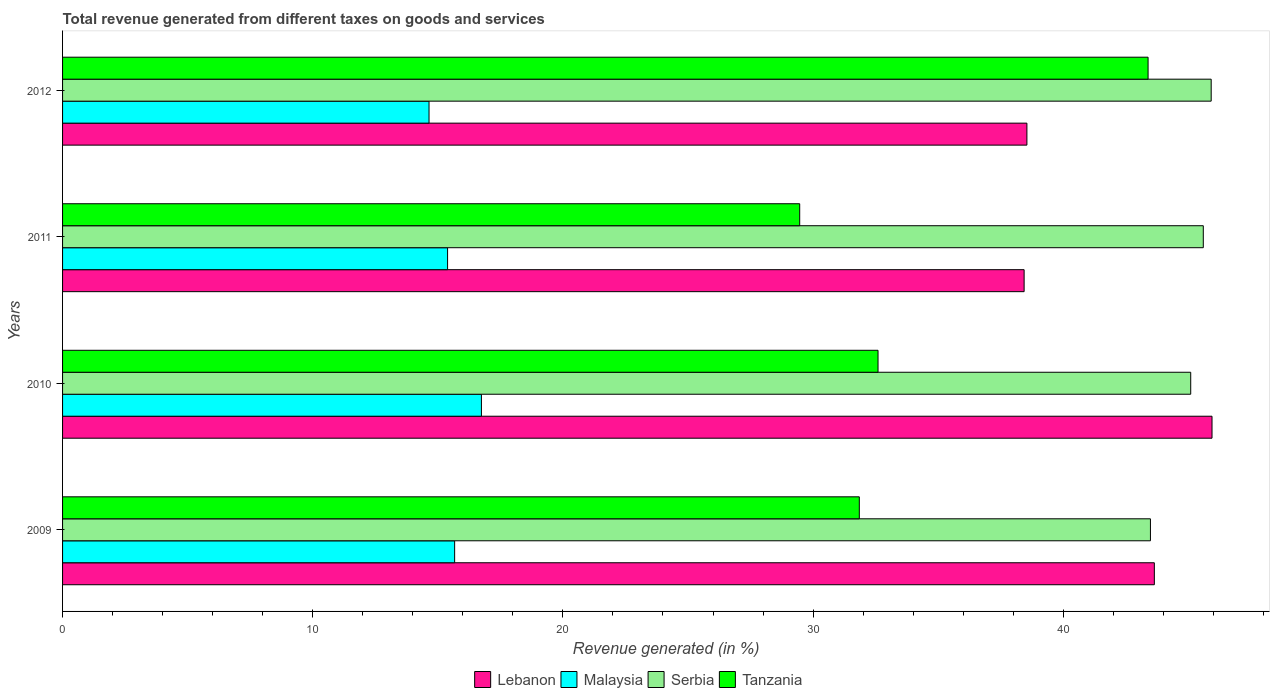How many different coloured bars are there?
Offer a terse response. 4. Are the number of bars on each tick of the Y-axis equal?
Offer a very short reply. Yes. How many bars are there on the 4th tick from the top?
Give a very brief answer. 4. How many bars are there on the 3rd tick from the bottom?
Your answer should be compact. 4. What is the total revenue generated in Tanzania in 2011?
Your response must be concise. 29.47. Across all years, what is the maximum total revenue generated in Malaysia?
Your answer should be compact. 16.74. Across all years, what is the minimum total revenue generated in Lebanon?
Provide a succinct answer. 38.44. In which year was the total revenue generated in Serbia maximum?
Make the answer very short. 2012. What is the total total revenue generated in Serbia in the graph?
Give a very brief answer. 180.09. What is the difference between the total revenue generated in Tanzania in 2009 and that in 2012?
Give a very brief answer. -11.54. What is the difference between the total revenue generated in Tanzania in 2010 and the total revenue generated in Lebanon in 2011?
Make the answer very short. -5.84. What is the average total revenue generated in Tanzania per year?
Keep it short and to the point. 34.32. In the year 2012, what is the difference between the total revenue generated in Tanzania and total revenue generated in Malaysia?
Provide a succinct answer. 28.74. What is the ratio of the total revenue generated in Lebanon in 2011 to that in 2012?
Provide a succinct answer. 1. Is the difference between the total revenue generated in Tanzania in 2009 and 2010 greater than the difference between the total revenue generated in Malaysia in 2009 and 2010?
Your answer should be very brief. Yes. What is the difference between the highest and the second highest total revenue generated in Lebanon?
Ensure brevity in your answer.  2.31. What is the difference between the highest and the lowest total revenue generated in Lebanon?
Your response must be concise. 7.51. In how many years, is the total revenue generated in Serbia greater than the average total revenue generated in Serbia taken over all years?
Provide a short and direct response. 3. What does the 3rd bar from the top in 2011 represents?
Give a very brief answer. Malaysia. What does the 4th bar from the bottom in 2012 represents?
Provide a short and direct response. Tanzania. How many bars are there?
Provide a short and direct response. 16. Are all the bars in the graph horizontal?
Offer a very short reply. Yes. How many years are there in the graph?
Make the answer very short. 4. Does the graph contain any zero values?
Give a very brief answer. No. How many legend labels are there?
Your response must be concise. 4. How are the legend labels stacked?
Ensure brevity in your answer.  Horizontal. What is the title of the graph?
Ensure brevity in your answer.  Total revenue generated from different taxes on goods and services. Does "Latin America(developing only)" appear as one of the legend labels in the graph?
Ensure brevity in your answer.  No. What is the label or title of the X-axis?
Your answer should be very brief. Revenue generated (in %). What is the label or title of the Y-axis?
Give a very brief answer. Years. What is the Revenue generated (in %) in Lebanon in 2009?
Your answer should be compact. 43.64. What is the Revenue generated (in %) in Malaysia in 2009?
Give a very brief answer. 15.67. What is the Revenue generated (in %) in Serbia in 2009?
Your answer should be very brief. 43.49. What is the Revenue generated (in %) of Tanzania in 2009?
Give a very brief answer. 31.85. What is the Revenue generated (in %) of Lebanon in 2010?
Provide a short and direct response. 45.95. What is the Revenue generated (in %) of Malaysia in 2010?
Make the answer very short. 16.74. What is the Revenue generated (in %) in Serbia in 2010?
Your answer should be very brief. 45.09. What is the Revenue generated (in %) in Tanzania in 2010?
Keep it short and to the point. 32.6. What is the Revenue generated (in %) in Lebanon in 2011?
Ensure brevity in your answer.  38.44. What is the Revenue generated (in %) in Malaysia in 2011?
Your answer should be very brief. 15.39. What is the Revenue generated (in %) in Serbia in 2011?
Provide a succinct answer. 45.6. What is the Revenue generated (in %) in Tanzania in 2011?
Ensure brevity in your answer.  29.47. What is the Revenue generated (in %) in Lebanon in 2012?
Offer a terse response. 38.55. What is the Revenue generated (in %) of Malaysia in 2012?
Your response must be concise. 14.65. What is the Revenue generated (in %) in Serbia in 2012?
Your answer should be compact. 45.91. What is the Revenue generated (in %) of Tanzania in 2012?
Make the answer very short. 43.39. Across all years, what is the maximum Revenue generated (in %) in Lebanon?
Make the answer very short. 45.95. Across all years, what is the maximum Revenue generated (in %) of Malaysia?
Give a very brief answer. 16.74. Across all years, what is the maximum Revenue generated (in %) of Serbia?
Your answer should be very brief. 45.91. Across all years, what is the maximum Revenue generated (in %) in Tanzania?
Give a very brief answer. 43.39. Across all years, what is the minimum Revenue generated (in %) in Lebanon?
Your answer should be very brief. 38.44. Across all years, what is the minimum Revenue generated (in %) of Malaysia?
Provide a short and direct response. 14.65. Across all years, what is the minimum Revenue generated (in %) in Serbia?
Your response must be concise. 43.49. Across all years, what is the minimum Revenue generated (in %) of Tanzania?
Ensure brevity in your answer.  29.47. What is the total Revenue generated (in %) in Lebanon in the graph?
Give a very brief answer. 166.57. What is the total Revenue generated (in %) in Malaysia in the graph?
Give a very brief answer. 62.45. What is the total Revenue generated (in %) of Serbia in the graph?
Ensure brevity in your answer.  180.09. What is the total Revenue generated (in %) in Tanzania in the graph?
Your answer should be very brief. 137.3. What is the difference between the Revenue generated (in %) of Lebanon in 2009 and that in 2010?
Make the answer very short. -2.31. What is the difference between the Revenue generated (in %) in Malaysia in 2009 and that in 2010?
Your answer should be very brief. -1.07. What is the difference between the Revenue generated (in %) of Serbia in 2009 and that in 2010?
Offer a very short reply. -1.61. What is the difference between the Revenue generated (in %) of Tanzania in 2009 and that in 2010?
Keep it short and to the point. -0.75. What is the difference between the Revenue generated (in %) in Lebanon in 2009 and that in 2011?
Keep it short and to the point. 5.21. What is the difference between the Revenue generated (in %) of Malaysia in 2009 and that in 2011?
Give a very brief answer. 0.28. What is the difference between the Revenue generated (in %) of Serbia in 2009 and that in 2011?
Give a very brief answer. -2.11. What is the difference between the Revenue generated (in %) in Tanzania in 2009 and that in 2011?
Your response must be concise. 2.38. What is the difference between the Revenue generated (in %) of Lebanon in 2009 and that in 2012?
Give a very brief answer. 5.09. What is the difference between the Revenue generated (in %) of Malaysia in 2009 and that in 2012?
Make the answer very short. 1.02. What is the difference between the Revenue generated (in %) in Serbia in 2009 and that in 2012?
Provide a short and direct response. -2.43. What is the difference between the Revenue generated (in %) in Tanzania in 2009 and that in 2012?
Ensure brevity in your answer.  -11.54. What is the difference between the Revenue generated (in %) in Lebanon in 2010 and that in 2011?
Your response must be concise. 7.51. What is the difference between the Revenue generated (in %) of Malaysia in 2010 and that in 2011?
Make the answer very short. 1.35. What is the difference between the Revenue generated (in %) of Serbia in 2010 and that in 2011?
Provide a succinct answer. -0.5. What is the difference between the Revenue generated (in %) in Tanzania in 2010 and that in 2011?
Make the answer very short. 3.13. What is the difference between the Revenue generated (in %) of Lebanon in 2010 and that in 2012?
Provide a succinct answer. 7.4. What is the difference between the Revenue generated (in %) of Malaysia in 2010 and that in 2012?
Your answer should be very brief. 2.09. What is the difference between the Revenue generated (in %) of Serbia in 2010 and that in 2012?
Your answer should be very brief. -0.82. What is the difference between the Revenue generated (in %) in Tanzania in 2010 and that in 2012?
Keep it short and to the point. -10.79. What is the difference between the Revenue generated (in %) in Lebanon in 2011 and that in 2012?
Make the answer very short. -0.11. What is the difference between the Revenue generated (in %) of Malaysia in 2011 and that in 2012?
Ensure brevity in your answer.  0.74. What is the difference between the Revenue generated (in %) of Serbia in 2011 and that in 2012?
Offer a terse response. -0.32. What is the difference between the Revenue generated (in %) of Tanzania in 2011 and that in 2012?
Provide a short and direct response. -13.93. What is the difference between the Revenue generated (in %) of Lebanon in 2009 and the Revenue generated (in %) of Malaysia in 2010?
Offer a terse response. 26.9. What is the difference between the Revenue generated (in %) of Lebanon in 2009 and the Revenue generated (in %) of Serbia in 2010?
Ensure brevity in your answer.  -1.45. What is the difference between the Revenue generated (in %) of Lebanon in 2009 and the Revenue generated (in %) of Tanzania in 2010?
Provide a short and direct response. 11.05. What is the difference between the Revenue generated (in %) in Malaysia in 2009 and the Revenue generated (in %) in Serbia in 2010?
Give a very brief answer. -29.42. What is the difference between the Revenue generated (in %) in Malaysia in 2009 and the Revenue generated (in %) in Tanzania in 2010?
Make the answer very short. -16.92. What is the difference between the Revenue generated (in %) in Serbia in 2009 and the Revenue generated (in %) in Tanzania in 2010?
Keep it short and to the point. 10.89. What is the difference between the Revenue generated (in %) of Lebanon in 2009 and the Revenue generated (in %) of Malaysia in 2011?
Offer a very short reply. 28.25. What is the difference between the Revenue generated (in %) of Lebanon in 2009 and the Revenue generated (in %) of Serbia in 2011?
Provide a short and direct response. -1.96. What is the difference between the Revenue generated (in %) of Lebanon in 2009 and the Revenue generated (in %) of Tanzania in 2011?
Make the answer very short. 14.18. What is the difference between the Revenue generated (in %) of Malaysia in 2009 and the Revenue generated (in %) of Serbia in 2011?
Ensure brevity in your answer.  -29.93. What is the difference between the Revenue generated (in %) in Malaysia in 2009 and the Revenue generated (in %) in Tanzania in 2011?
Keep it short and to the point. -13.79. What is the difference between the Revenue generated (in %) in Serbia in 2009 and the Revenue generated (in %) in Tanzania in 2011?
Give a very brief answer. 14.02. What is the difference between the Revenue generated (in %) of Lebanon in 2009 and the Revenue generated (in %) of Malaysia in 2012?
Provide a short and direct response. 28.99. What is the difference between the Revenue generated (in %) in Lebanon in 2009 and the Revenue generated (in %) in Serbia in 2012?
Offer a terse response. -2.27. What is the difference between the Revenue generated (in %) of Lebanon in 2009 and the Revenue generated (in %) of Tanzania in 2012?
Your answer should be very brief. 0.25. What is the difference between the Revenue generated (in %) in Malaysia in 2009 and the Revenue generated (in %) in Serbia in 2012?
Ensure brevity in your answer.  -30.24. What is the difference between the Revenue generated (in %) in Malaysia in 2009 and the Revenue generated (in %) in Tanzania in 2012?
Give a very brief answer. -27.72. What is the difference between the Revenue generated (in %) in Serbia in 2009 and the Revenue generated (in %) in Tanzania in 2012?
Ensure brevity in your answer.  0.09. What is the difference between the Revenue generated (in %) of Lebanon in 2010 and the Revenue generated (in %) of Malaysia in 2011?
Provide a short and direct response. 30.56. What is the difference between the Revenue generated (in %) in Lebanon in 2010 and the Revenue generated (in %) in Serbia in 2011?
Provide a succinct answer. 0.35. What is the difference between the Revenue generated (in %) of Lebanon in 2010 and the Revenue generated (in %) of Tanzania in 2011?
Keep it short and to the point. 16.48. What is the difference between the Revenue generated (in %) of Malaysia in 2010 and the Revenue generated (in %) of Serbia in 2011?
Keep it short and to the point. -28.85. What is the difference between the Revenue generated (in %) of Malaysia in 2010 and the Revenue generated (in %) of Tanzania in 2011?
Your answer should be very brief. -12.72. What is the difference between the Revenue generated (in %) in Serbia in 2010 and the Revenue generated (in %) in Tanzania in 2011?
Provide a succinct answer. 15.63. What is the difference between the Revenue generated (in %) in Lebanon in 2010 and the Revenue generated (in %) in Malaysia in 2012?
Give a very brief answer. 31.3. What is the difference between the Revenue generated (in %) in Lebanon in 2010 and the Revenue generated (in %) in Serbia in 2012?
Offer a very short reply. 0.03. What is the difference between the Revenue generated (in %) of Lebanon in 2010 and the Revenue generated (in %) of Tanzania in 2012?
Offer a terse response. 2.56. What is the difference between the Revenue generated (in %) in Malaysia in 2010 and the Revenue generated (in %) in Serbia in 2012?
Your answer should be compact. -29.17. What is the difference between the Revenue generated (in %) of Malaysia in 2010 and the Revenue generated (in %) of Tanzania in 2012?
Your response must be concise. -26.65. What is the difference between the Revenue generated (in %) in Serbia in 2010 and the Revenue generated (in %) in Tanzania in 2012?
Ensure brevity in your answer.  1.7. What is the difference between the Revenue generated (in %) in Lebanon in 2011 and the Revenue generated (in %) in Malaysia in 2012?
Your answer should be compact. 23.79. What is the difference between the Revenue generated (in %) in Lebanon in 2011 and the Revenue generated (in %) in Serbia in 2012?
Ensure brevity in your answer.  -7.48. What is the difference between the Revenue generated (in %) of Lebanon in 2011 and the Revenue generated (in %) of Tanzania in 2012?
Offer a very short reply. -4.96. What is the difference between the Revenue generated (in %) of Malaysia in 2011 and the Revenue generated (in %) of Serbia in 2012?
Provide a short and direct response. -30.52. What is the difference between the Revenue generated (in %) of Malaysia in 2011 and the Revenue generated (in %) of Tanzania in 2012?
Your answer should be very brief. -28. What is the difference between the Revenue generated (in %) in Serbia in 2011 and the Revenue generated (in %) in Tanzania in 2012?
Give a very brief answer. 2.21. What is the average Revenue generated (in %) in Lebanon per year?
Your response must be concise. 41.64. What is the average Revenue generated (in %) in Malaysia per year?
Ensure brevity in your answer.  15.61. What is the average Revenue generated (in %) in Serbia per year?
Offer a terse response. 45.02. What is the average Revenue generated (in %) of Tanzania per year?
Offer a terse response. 34.32. In the year 2009, what is the difference between the Revenue generated (in %) in Lebanon and Revenue generated (in %) in Malaysia?
Make the answer very short. 27.97. In the year 2009, what is the difference between the Revenue generated (in %) of Lebanon and Revenue generated (in %) of Serbia?
Give a very brief answer. 0.16. In the year 2009, what is the difference between the Revenue generated (in %) of Lebanon and Revenue generated (in %) of Tanzania?
Give a very brief answer. 11.79. In the year 2009, what is the difference between the Revenue generated (in %) in Malaysia and Revenue generated (in %) in Serbia?
Your response must be concise. -27.81. In the year 2009, what is the difference between the Revenue generated (in %) in Malaysia and Revenue generated (in %) in Tanzania?
Your answer should be very brief. -16.18. In the year 2009, what is the difference between the Revenue generated (in %) in Serbia and Revenue generated (in %) in Tanzania?
Provide a short and direct response. 11.64. In the year 2010, what is the difference between the Revenue generated (in %) of Lebanon and Revenue generated (in %) of Malaysia?
Offer a very short reply. 29.2. In the year 2010, what is the difference between the Revenue generated (in %) in Lebanon and Revenue generated (in %) in Serbia?
Your answer should be very brief. 0.85. In the year 2010, what is the difference between the Revenue generated (in %) of Lebanon and Revenue generated (in %) of Tanzania?
Your response must be concise. 13.35. In the year 2010, what is the difference between the Revenue generated (in %) of Malaysia and Revenue generated (in %) of Serbia?
Provide a succinct answer. -28.35. In the year 2010, what is the difference between the Revenue generated (in %) in Malaysia and Revenue generated (in %) in Tanzania?
Make the answer very short. -15.85. In the year 2010, what is the difference between the Revenue generated (in %) of Serbia and Revenue generated (in %) of Tanzania?
Provide a succinct answer. 12.5. In the year 2011, what is the difference between the Revenue generated (in %) of Lebanon and Revenue generated (in %) of Malaysia?
Your answer should be compact. 23.05. In the year 2011, what is the difference between the Revenue generated (in %) in Lebanon and Revenue generated (in %) in Serbia?
Offer a very short reply. -7.16. In the year 2011, what is the difference between the Revenue generated (in %) of Lebanon and Revenue generated (in %) of Tanzania?
Keep it short and to the point. 8.97. In the year 2011, what is the difference between the Revenue generated (in %) in Malaysia and Revenue generated (in %) in Serbia?
Offer a very short reply. -30.21. In the year 2011, what is the difference between the Revenue generated (in %) of Malaysia and Revenue generated (in %) of Tanzania?
Give a very brief answer. -14.08. In the year 2011, what is the difference between the Revenue generated (in %) in Serbia and Revenue generated (in %) in Tanzania?
Your answer should be very brief. 16.13. In the year 2012, what is the difference between the Revenue generated (in %) of Lebanon and Revenue generated (in %) of Malaysia?
Your response must be concise. 23.9. In the year 2012, what is the difference between the Revenue generated (in %) in Lebanon and Revenue generated (in %) in Serbia?
Your answer should be compact. -7.37. In the year 2012, what is the difference between the Revenue generated (in %) of Lebanon and Revenue generated (in %) of Tanzania?
Your response must be concise. -4.84. In the year 2012, what is the difference between the Revenue generated (in %) of Malaysia and Revenue generated (in %) of Serbia?
Ensure brevity in your answer.  -31.26. In the year 2012, what is the difference between the Revenue generated (in %) of Malaysia and Revenue generated (in %) of Tanzania?
Offer a very short reply. -28.74. In the year 2012, what is the difference between the Revenue generated (in %) of Serbia and Revenue generated (in %) of Tanzania?
Ensure brevity in your answer.  2.52. What is the ratio of the Revenue generated (in %) of Lebanon in 2009 to that in 2010?
Offer a terse response. 0.95. What is the ratio of the Revenue generated (in %) in Malaysia in 2009 to that in 2010?
Provide a succinct answer. 0.94. What is the ratio of the Revenue generated (in %) in Serbia in 2009 to that in 2010?
Give a very brief answer. 0.96. What is the ratio of the Revenue generated (in %) of Tanzania in 2009 to that in 2010?
Ensure brevity in your answer.  0.98. What is the ratio of the Revenue generated (in %) of Lebanon in 2009 to that in 2011?
Your answer should be very brief. 1.14. What is the ratio of the Revenue generated (in %) in Malaysia in 2009 to that in 2011?
Your answer should be compact. 1.02. What is the ratio of the Revenue generated (in %) of Serbia in 2009 to that in 2011?
Your answer should be very brief. 0.95. What is the ratio of the Revenue generated (in %) of Tanzania in 2009 to that in 2011?
Provide a succinct answer. 1.08. What is the ratio of the Revenue generated (in %) of Lebanon in 2009 to that in 2012?
Provide a succinct answer. 1.13. What is the ratio of the Revenue generated (in %) of Malaysia in 2009 to that in 2012?
Provide a short and direct response. 1.07. What is the ratio of the Revenue generated (in %) of Serbia in 2009 to that in 2012?
Offer a very short reply. 0.95. What is the ratio of the Revenue generated (in %) in Tanzania in 2009 to that in 2012?
Provide a short and direct response. 0.73. What is the ratio of the Revenue generated (in %) in Lebanon in 2010 to that in 2011?
Make the answer very short. 1.2. What is the ratio of the Revenue generated (in %) in Malaysia in 2010 to that in 2011?
Offer a terse response. 1.09. What is the ratio of the Revenue generated (in %) of Tanzania in 2010 to that in 2011?
Keep it short and to the point. 1.11. What is the ratio of the Revenue generated (in %) of Lebanon in 2010 to that in 2012?
Your response must be concise. 1.19. What is the ratio of the Revenue generated (in %) in Malaysia in 2010 to that in 2012?
Keep it short and to the point. 1.14. What is the ratio of the Revenue generated (in %) in Serbia in 2010 to that in 2012?
Ensure brevity in your answer.  0.98. What is the ratio of the Revenue generated (in %) of Tanzania in 2010 to that in 2012?
Your answer should be compact. 0.75. What is the ratio of the Revenue generated (in %) of Lebanon in 2011 to that in 2012?
Ensure brevity in your answer.  1. What is the ratio of the Revenue generated (in %) in Malaysia in 2011 to that in 2012?
Offer a terse response. 1.05. What is the ratio of the Revenue generated (in %) of Serbia in 2011 to that in 2012?
Your answer should be very brief. 0.99. What is the ratio of the Revenue generated (in %) of Tanzania in 2011 to that in 2012?
Your answer should be compact. 0.68. What is the difference between the highest and the second highest Revenue generated (in %) in Lebanon?
Offer a terse response. 2.31. What is the difference between the highest and the second highest Revenue generated (in %) of Malaysia?
Offer a terse response. 1.07. What is the difference between the highest and the second highest Revenue generated (in %) in Serbia?
Offer a very short reply. 0.32. What is the difference between the highest and the second highest Revenue generated (in %) in Tanzania?
Your response must be concise. 10.79. What is the difference between the highest and the lowest Revenue generated (in %) in Lebanon?
Provide a short and direct response. 7.51. What is the difference between the highest and the lowest Revenue generated (in %) in Malaysia?
Offer a very short reply. 2.09. What is the difference between the highest and the lowest Revenue generated (in %) of Serbia?
Make the answer very short. 2.43. What is the difference between the highest and the lowest Revenue generated (in %) of Tanzania?
Give a very brief answer. 13.93. 